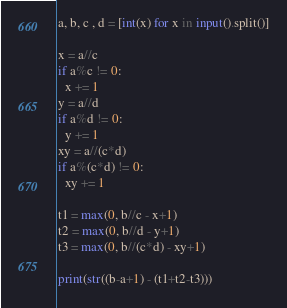<code> <loc_0><loc_0><loc_500><loc_500><_Python_>a, b, c , d = [int(x) for x in input().split()]

x = a//c
if a%c != 0:
  x += 1
y = a//d
if a%d != 0:
  y += 1
xy = a//(c*d)
if a%(c*d) != 0:
  xy += 1

t1 = max(0, b//c - x+1)
t2 = max(0, b//d - y+1)
t3 = max(0, b//(c*d) - xy+1)

print(str((b-a+1) - (t1+t2-t3)))

</code> 